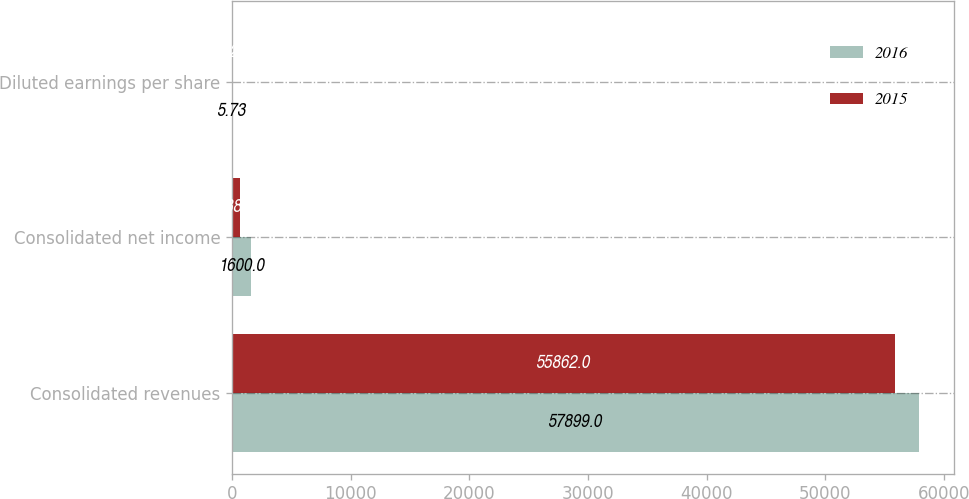<chart> <loc_0><loc_0><loc_500><loc_500><stacked_bar_chart><ecel><fcel>Consolidated revenues<fcel>Consolidated net income<fcel>Diluted earnings per share<nl><fcel>2016<fcel>57899<fcel>1600<fcel>5.73<nl><fcel>2015<fcel>55862<fcel>638<fcel>2.22<nl></chart> 